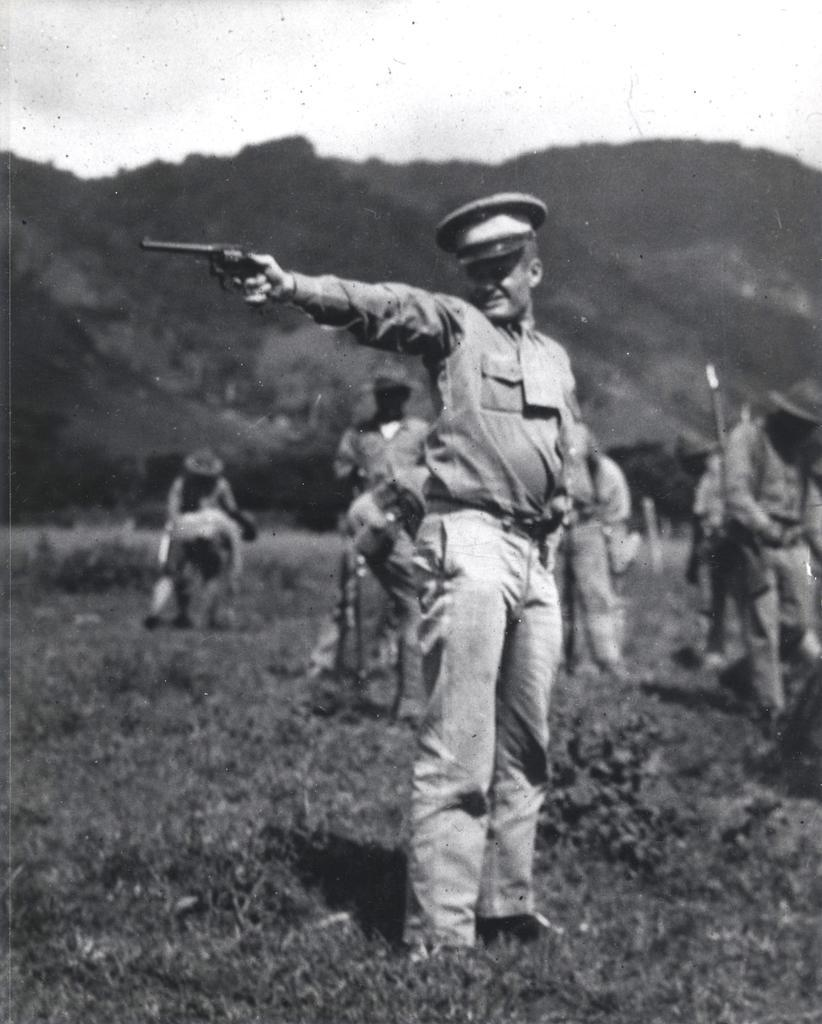What is the color scheme of the image? The image is black and white and white. What is the person in the image holding? The person is holding a gun in the image. Where is the person standing? The person is standing on the grass. What can be seen in the background of the image? In the background of the image, there are people, plants, trees, a hill, and the sky. What type of toothpaste is the person using in the image? There is no toothpaste present in the image. What kind of battle is taking place in the image? There is no battle depicted in the image. 